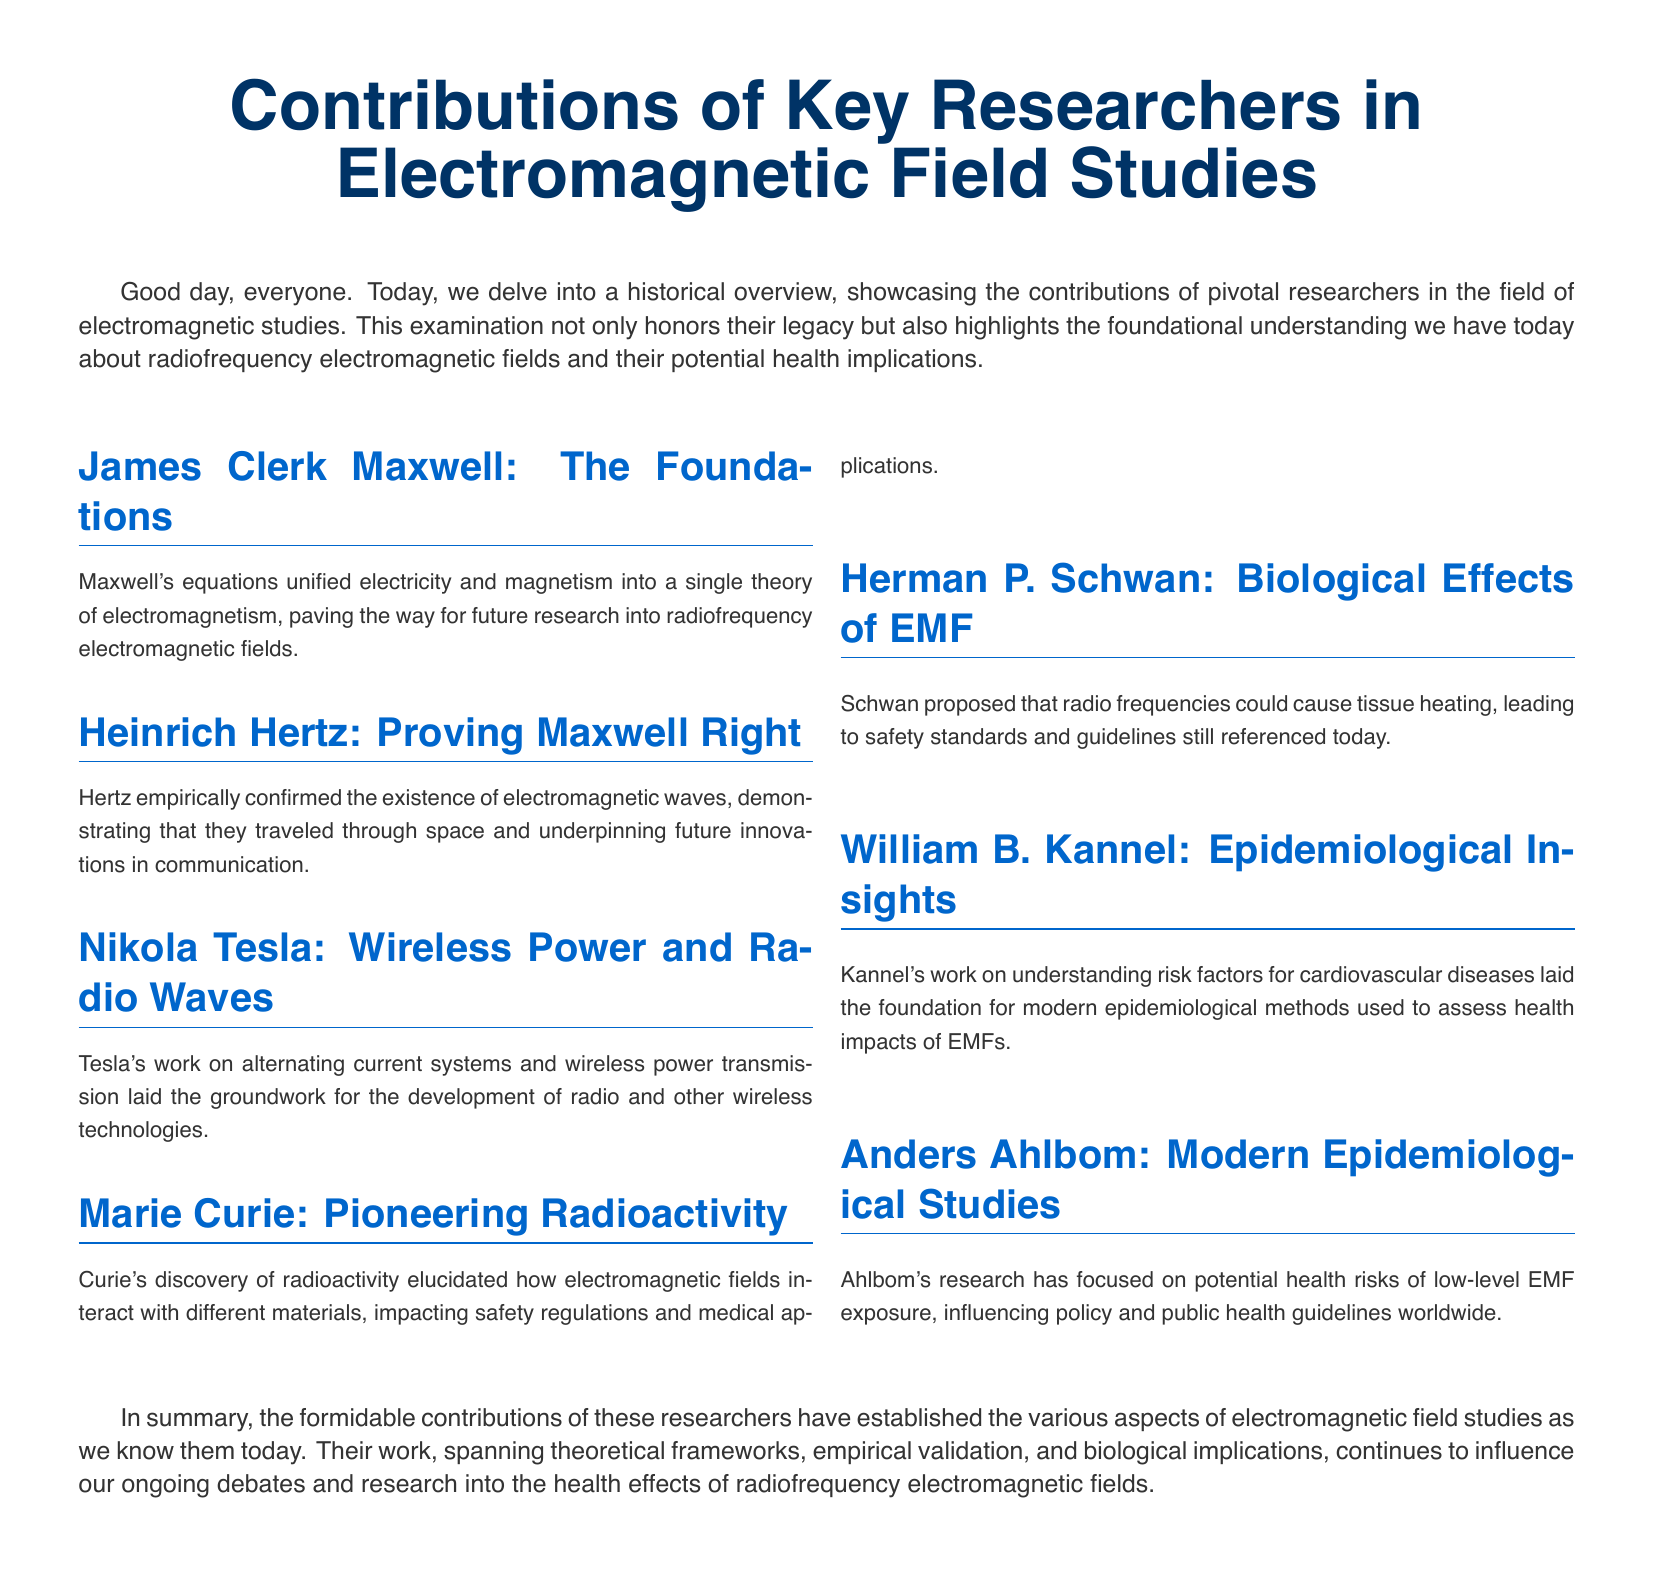What were Maxwell's contributions? Maxwell's contributions unified electricity and magnetism into a single theory of electromagnetism.
Answer: Unified electricity and magnetism Who confirmed the existence of electromagnetic waves? Hertz empirically confirmed the existence of electromagnetic waves, demonstrating their propagation through space.
Answer: Hertz What did Tesla work on? Tesla worked on alternating current systems and wireless power transmission, affecting radio and wireless technologies.
Answer: Alternating current systems and wireless power transmission What did Curie's discoveries impact? Curie's discovery of radioactivity impacted safety regulations and medical applications regarding electromagnetic fields.
Answer: Safety regulations and medical applications What health risk did Schwan propose regarding EMF? Schwan proposed that radio frequencies could cause tissue heating, influencing safety standards.
Answer: Tissue heating Who focused on low-level EMF exposure? Ahlbom's research has focused on potential health risks of low-level EMF exposure.
Answer: Ahlbom What type of research did Kannel contribute to? Kannel's work laid the foundation for modern epidemiological methods used to assess health impacts of EMFs.
Answer: Epidemiological methods Which section discusses biological effects of EMF? The section discussing biological effects of EMF is attributed to Herman P. Schwan.
Answer: Herman P. Schwan What is the document's main subject? The main subject of the document is the contributions of key researchers in electromagnetic field studies.
Answer: Contributions of key researchers in electromagnetic field studies 